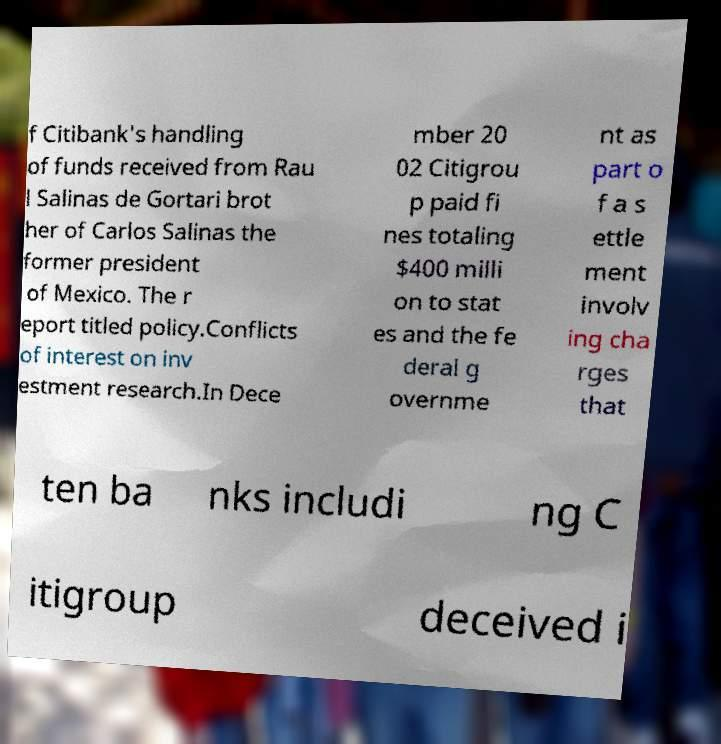Could you assist in decoding the text presented in this image and type it out clearly? f Citibank's handling of funds received from Rau l Salinas de Gortari brot her of Carlos Salinas the former president of Mexico. The r eport titled policy.Conflicts of interest on inv estment research.In Dece mber 20 02 Citigrou p paid fi nes totaling $400 milli on to stat es and the fe deral g overnme nt as part o f a s ettle ment involv ing cha rges that ten ba nks includi ng C itigroup deceived i 